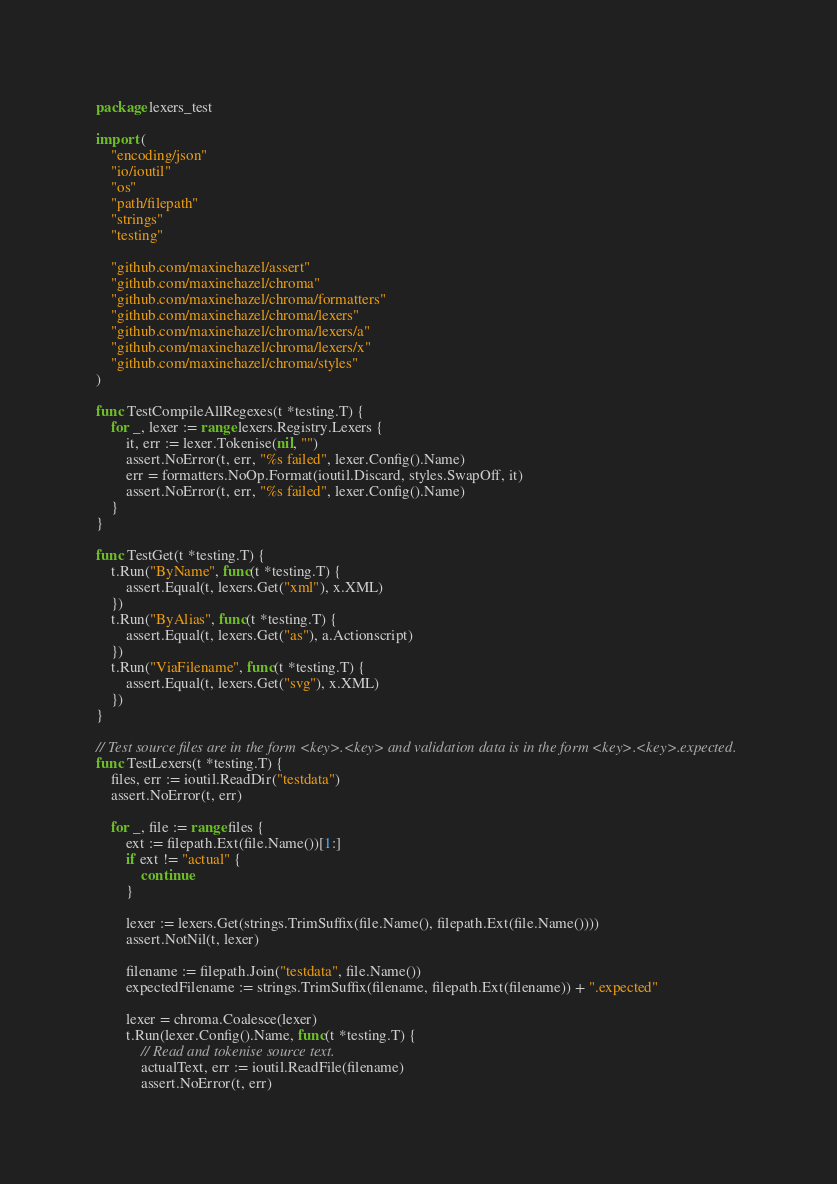Convert code to text. <code><loc_0><loc_0><loc_500><loc_500><_Go_>package lexers_test

import (
	"encoding/json"
	"io/ioutil"
	"os"
	"path/filepath"
	"strings"
	"testing"

	"github.com/maxinehazel/assert"
	"github.com/maxinehazel/chroma"
	"github.com/maxinehazel/chroma/formatters"
	"github.com/maxinehazel/chroma/lexers"
	"github.com/maxinehazel/chroma/lexers/a"
	"github.com/maxinehazel/chroma/lexers/x"
	"github.com/maxinehazel/chroma/styles"
)

func TestCompileAllRegexes(t *testing.T) {
	for _, lexer := range lexers.Registry.Lexers {
		it, err := lexer.Tokenise(nil, "")
		assert.NoError(t, err, "%s failed", lexer.Config().Name)
		err = formatters.NoOp.Format(ioutil.Discard, styles.SwapOff, it)
		assert.NoError(t, err, "%s failed", lexer.Config().Name)
	}
}

func TestGet(t *testing.T) {
	t.Run("ByName", func(t *testing.T) {
		assert.Equal(t, lexers.Get("xml"), x.XML)
	})
	t.Run("ByAlias", func(t *testing.T) {
		assert.Equal(t, lexers.Get("as"), a.Actionscript)
	})
	t.Run("ViaFilename", func(t *testing.T) {
		assert.Equal(t, lexers.Get("svg"), x.XML)
	})
}

// Test source files are in the form <key>.<key> and validation data is in the form <key>.<key>.expected.
func TestLexers(t *testing.T) {
	files, err := ioutil.ReadDir("testdata")
	assert.NoError(t, err)

	for _, file := range files {
		ext := filepath.Ext(file.Name())[1:]
		if ext != "actual" {
			continue
		}

		lexer := lexers.Get(strings.TrimSuffix(file.Name(), filepath.Ext(file.Name())))
		assert.NotNil(t, lexer)

		filename := filepath.Join("testdata", file.Name())
		expectedFilename := strings.TrimSuffix(filename, filepath.Ext(filename)) + ".expected"

		lexer = chroma.Coalesce(lexer)
		t.Run(lexer.Config().Name, func(t *testing.T) {
			// Read and tokenise source text.
			actualText, err := ioutil.ReadFile(filename)
			assert.NoError(t, err)</code> 